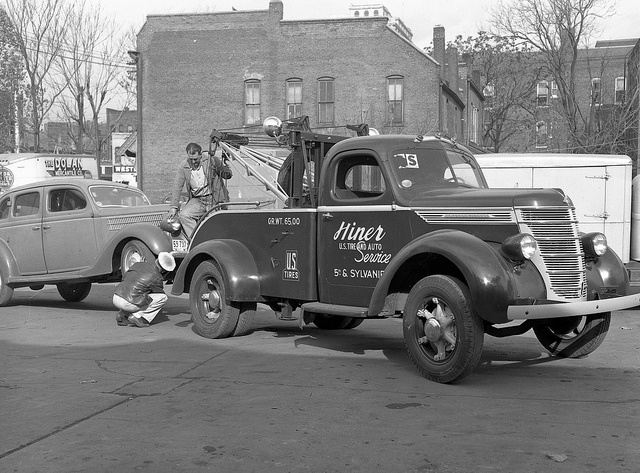Describe the objects in this image and their specific colors. I can see truck in white, gray, black, darkgray, and lightgray tones, car in white, darkgray, gray, black, and lightgray tones, people in white, darkgray, gray, lightgray, and black tones, people in white, gray, lightgray, darkgray, and black tones, and bird in darkgray, lightgray, gray, and white tones in this image. 